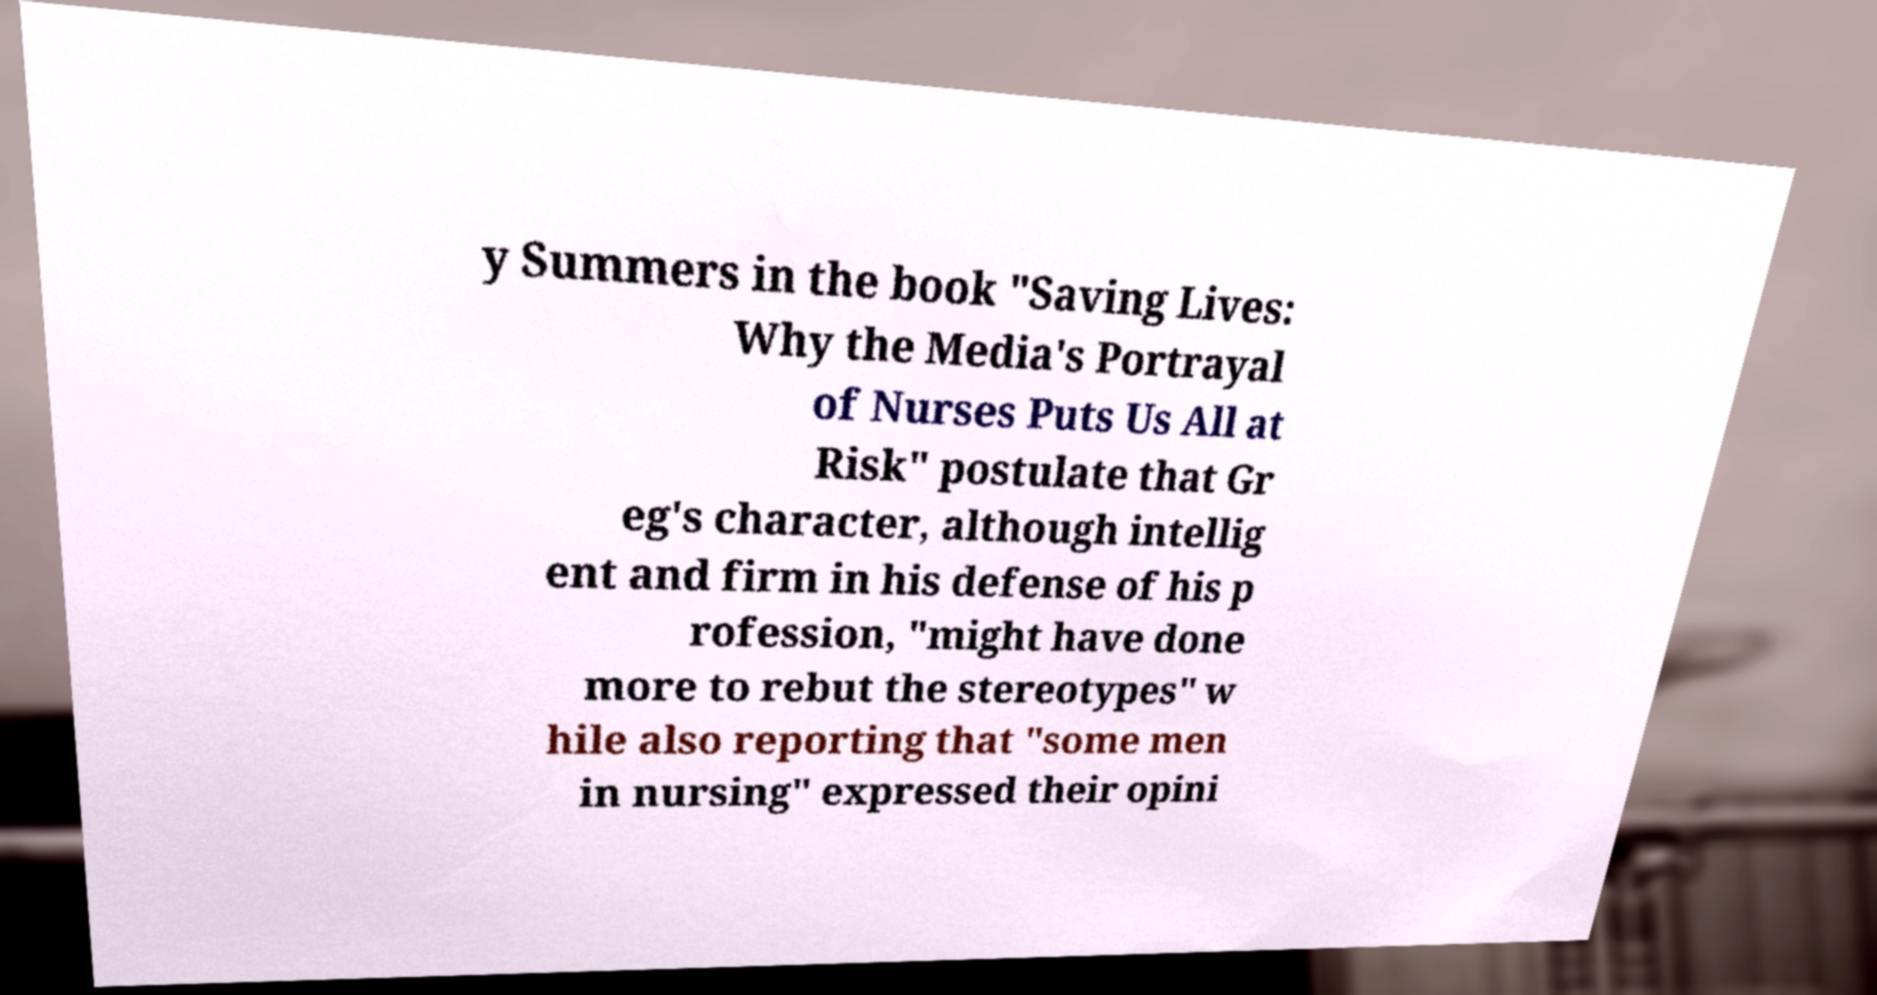Could you assist in decoding the text presented in this image and type it out clearly? y Summers in the book "Saving Lives: Why the Media's Portrayal of Nurses Puts Us All at Risk" postulate that Gr eg's character, although intellig ent and firm in his defense of his p rofession, "might have done more to rebut the stereotypes" w hile also reporting that "some men in nursing" expressed their opini 